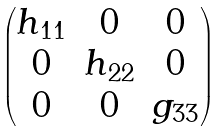<formula> <loc_0><loc_0><loc_500><loc_500>\begin{pmatrix} h _ { 1 1 } & 0 & 0 \\ 0 & h _ { 2 2 } & 0 \\ 0 & 0 & g _ { 3 3 } \\ \end{pmatrix}</formula> 